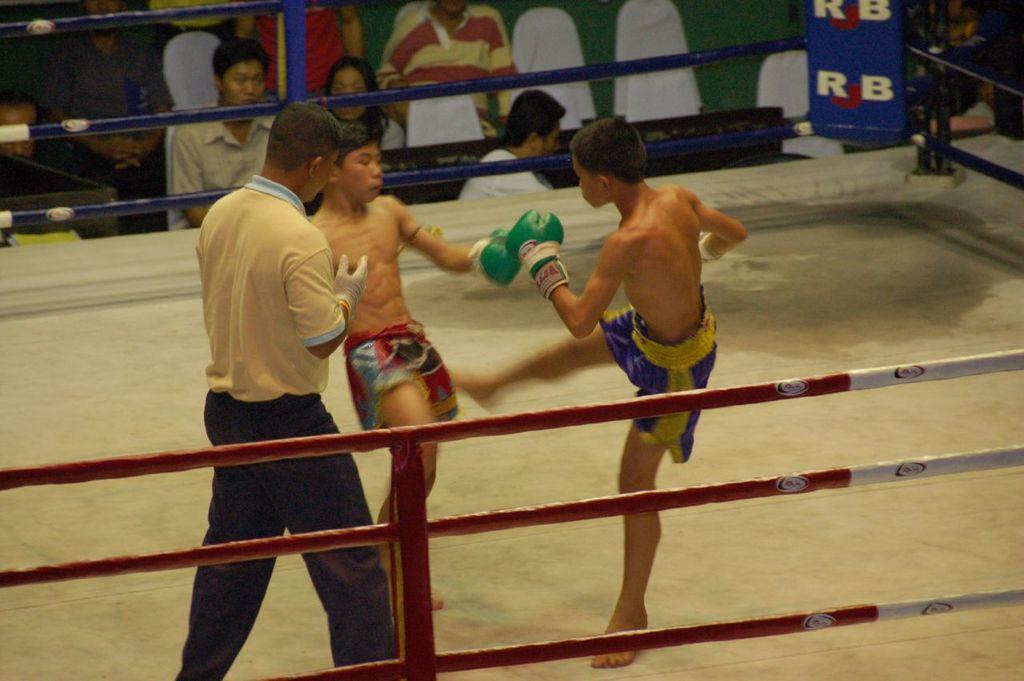What two letters are on the ring post?
Offer a very short reply. Rb. 